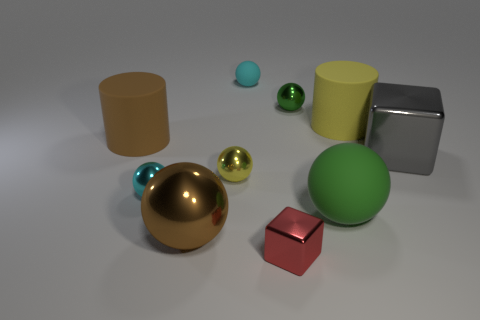How many objects are small cyan shiny cylinders or tiny cyan balls?
Provide a succinct answer. 2. There is a green object that is behind the tiny yellow sphere; how many objects are on the right side of it?
Your response must be concise. 3. How many other things are the same size as the brown cylinder?
Your answer should be compact. 4. The other sphere that is the same color as the large matte sphere is what size?
Your answer should be compact. Small. Do the cyan object that is right of the cyan metallic sphere and the large brown shiny thing have the same shape?
Keep it short and to the point. Yes. What material is the cyan sphere that is on the left side of the yellow ball?
Give a very brief answer. Metal. What shape is the thing that is the same color as the big metal ball?
Provide a short and direct response. Cylinder. Are there any red cubes that have the same material as the large gray cube?
Make the answer very short. Yes. The brown sphere is what size?
Offer a very short reply. Large. What number of green objects are large things or large metal balls?
Make the answer very short. 1. 